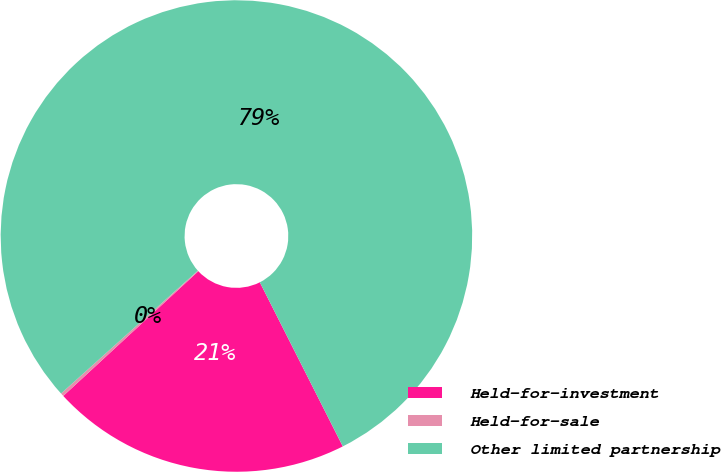Convert chart. <chart><loc_0><loc_0><loc_500><loc_500><pie_chart><fcel>Held-for-investment<fcel>Held-for-sale<fcel>Other limited partnership<nl><fcel>20.58%<fcel>0.22%<fcel>79.19%<nl></chart> 